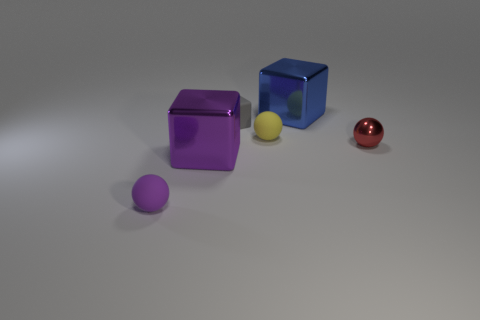How many matte things are either tiny red cubes or big blue cubes? In the image, there is one big blue cube and no tiny red cubes, making the total count of matte things that are either tiny red cubes or big blue cubes equal to 1. 